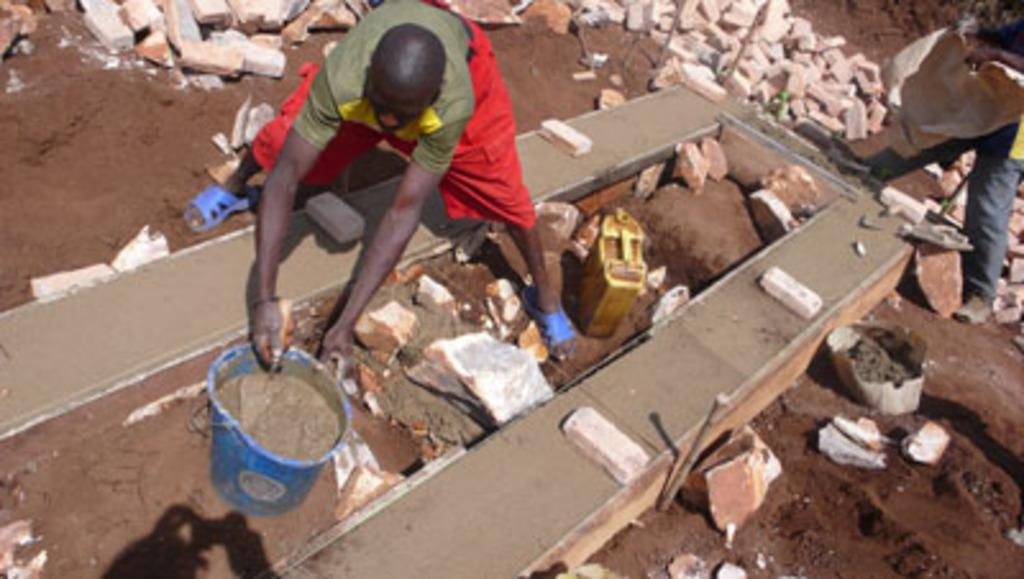What is the primary activity of the people in the image? The people in the image are on the ground, but their specific activity is not mentioned in the facts. What type of structure is depicted in the image? There is a wall in the image, and it is made of bricks. What items are related to water in the image? A bucket and a water can are visible in the image. What type of surface is present in the image? Soil is present in the image. What other unspecified objects are present in the image? There are some unspecified objects in the image, but their nature is not mentioned in the facts. What type of food is being served in the image? There is no mention of food in the image or the provided facts. How does the pollution affect the people in the image? There is no mention of pollution in the image or the provided facts. 